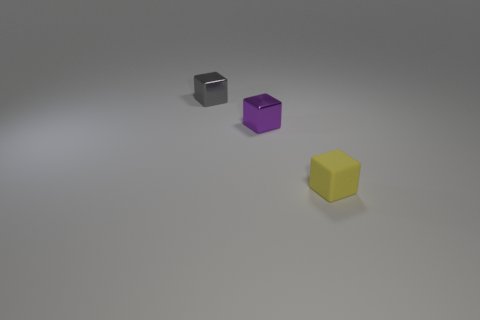What is the size of the purple shiny object that is the same shape as the yellow matte object? The purple shiny object has a small size, comparable to a standard six-sided dice commonly used in board games. It shares the same cube shape as the larger yellow matte object in the image. 